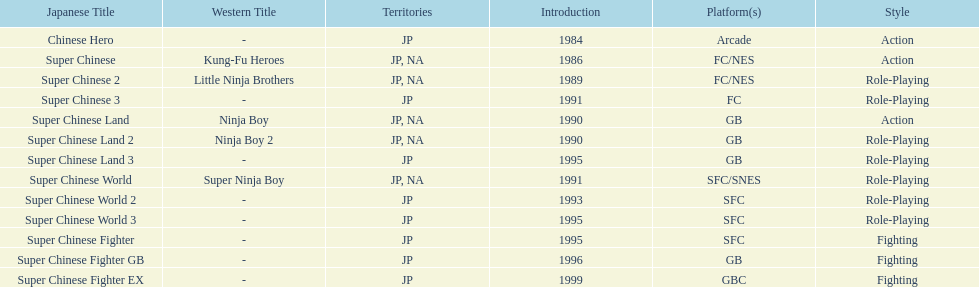Which platforms had the most titles released? GB. Write the full table. {'header': ['Japanese Title', 'Western Title', 'Territories', 'Introduction', 'Platform(s)', 'Style'], 'rows': [['Chinese Hero', '-', 'JP', '1984', 'Arcade', 'Action'], ['Super Chinese', 'Kung-Fu Heroes', 'JP, NA', '1986', 'FC/NES', 'Action'], ['Super Chinese 2', 'Little Ninja Brothers', 'JP, NA', '1989', 'FC/NES', 'Role-Playing'], ['Super Chinese 3', '-', 'JP', '1991', 'FC', 'Role-Playing'], ['Super Chinese Land', 'Ninja Boy', 'JP, NA', '1990', 'GB', 'Action'], ['Super Chinese Land 2', 'Ninja Boy 2', 'JP, NA', '1990', 'GB', 'Role-Playing'], ['Super Chinese Land 3', '-', 'JP', '1995', 'GB', 'Role-Playing'], ['Super Chinese World', 'Super Ninja Boy', 'JP, NA', '1991', 'SFC/SNES', 'Role-Playing'], ['Super Chinese World 2', '-', 'JP', '1993', 'SFC', 'Role-Playing'], ['Super Chinese World 3', '-', 'JP', '1995', 'SFC', 'Role-Playing'], ['Super Chinese Fighter', '-', 'JP', '1995', 'SFC', 'Fighting'], ['Super Chinese Fighter GB', '-', 'JP', '1996', 'GB', 'Fighting'], ['Super Chinese Fighter EX', '-', 'JP', '1999', 'GBC', 'Fighting']]} 